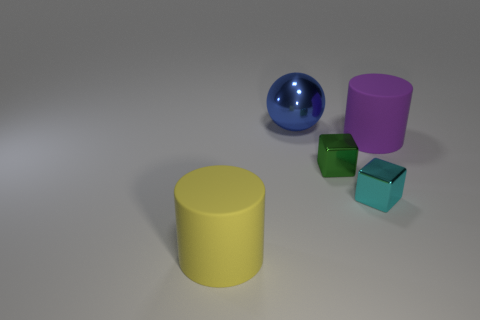Subtract all cylinders. How many objects are left? 3 Subtract all brown cylinders. How many cyan blocks are left? 1 Add 1 green metal things. How many green metal things exist? 2 Add 3 blocks. How many objects exist? 8 Subtract 0 yellow balls. How many objects are left? 5 Subtract 2 cylinders. How many cylinders are left? 0 Subtract all yellow cubes. Subtract all green balls. How many cubes are left? 2 Subtract all large brown rubber cylinders. Subtract all big blue shiny spheres. How many objects are left? 4 Add 4 large purple cylinders. How many large purple cylinders are left? 5 